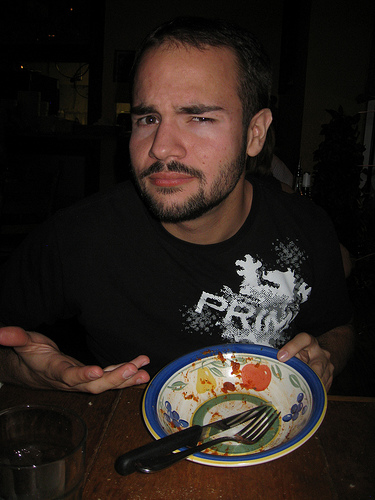<image>
Is the bowl in front of the man? Yes. The bowl is positioned in front of the man, appearing closer to the camera viewpoint. 